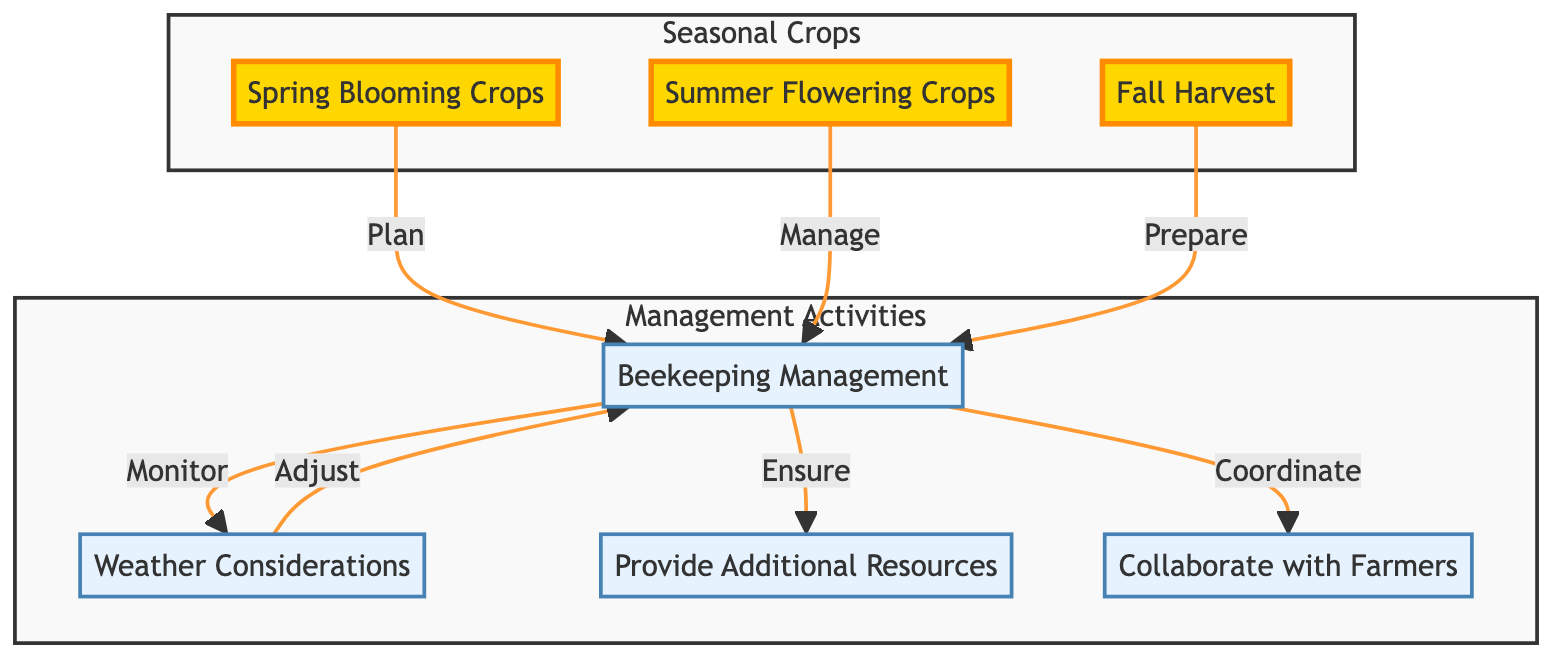What are the three types of seasonal crops listed in the diagram? The diagram includes three types of seasonal crops, represented by the nodes labeled "Spring Blooming Crops," "Summer Flowering Crops," and "Fall Harvest."
Answer: Spring Blooming Crops, Summer Flowering Crops, Fall Harvest How many management activities are mentioned in the diagram? The diagram includes four management activities represented by the nodes "Beekeeping Management," "Weather Considerations," "Provide Additional Resources," and "Collaborate with Farmers," totaling four activities.
Answer: 4 Which seasonal crop is connected to the "Beekeeping Management" process with a "Plan" relationship? The node "Spring Blooming Crops" is connected to "Beekeeping Management" with a "Plan" relationship, indicating that planning is essential for this type of crop.
Answer: Spring Blooming Crops What is the main action taken after monitoring weather considerations? After "Monitoring" weather conditions, the next action is to "Adjust" the beekeeping management activities, indicating that changes are made based on weather effects.
Answer: Adjust What does the "Beekeeping Management" node ensure regarding additional resources? The "Beekeeping Management" node is connected with an "Ensure" relationship to the "Provide Additional Resources" node, meaning it is responsible for ensuring these resources are available to support bee populations.
Answer: Ensure How does "Summer Flowering Crops" interact with "Beekeeping Management"? "Summer Flowering Crops" interacts with "Beekeeping Management" through the "Manage" relationship, indicating the importance of management for the success of summer crops.
Answer: Manage What is the primary purpose of collaborating with farmers according to the diagram? The diagram suggests that collaborating with farmers serves the purpose of coordinating crop planting and pollination schedules to optimize pollination efficiency.
Answer: Coordinate Which node does the "Prepare" relationship lead to from "Fall Harvest"? The "Prepare" relationship from "Fall Harvest" leads to the "Beekeeping Management" node, indicating preparation is essential for the management of beekeeping during the fall harvesting period.
Answer: Beekeeping Management 